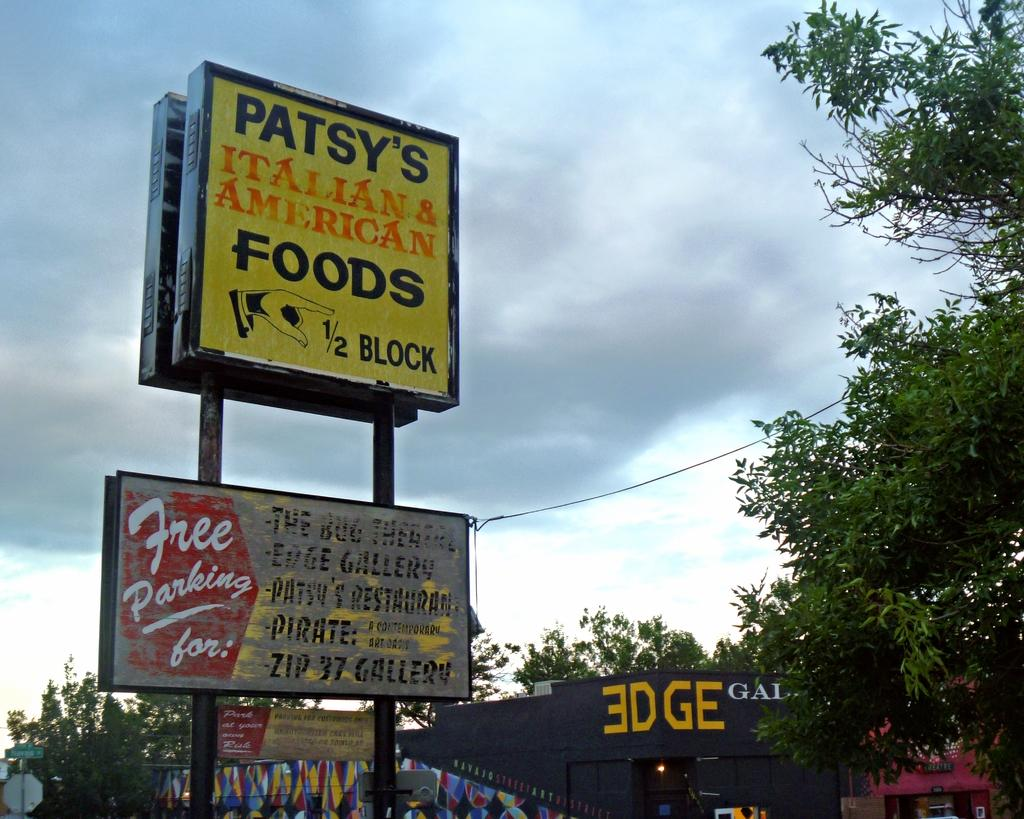<image>
Provide a brief description of the given image. A street sign for Patsy's Italian and American Foods. 